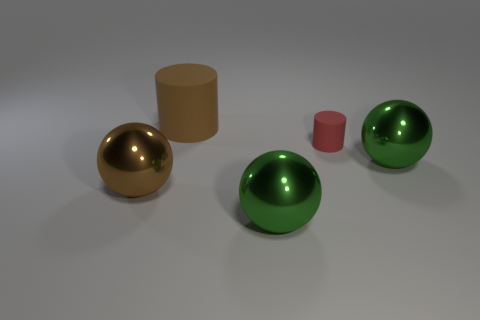Subtract all green spheres. How many spheres are left? 1 Add 3 spheres. How many objects exist? 8 Subtract all cylinders. How many objects are left? 3 Add 2 big purple metallic cubes. How many big purple metallic cubes exist? 2 Subtract 0 red cubes. How many objects are left? 5 Subtract all brown balls. Subtract all brown shiny objects. How many objects are left? 3 Add 2 large brown things. How many large brown things are left? 4 